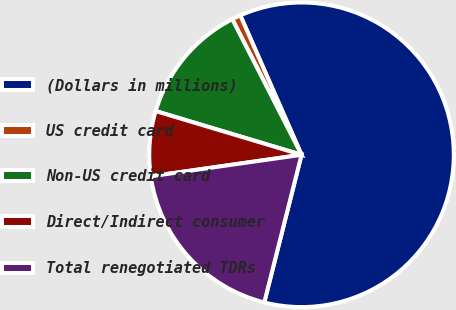Convert chart. <chart><loc_0><loc_0><loc_500><loc_500><pie_chart><fcel>(Dollars in millions)<fcel>US credit card<fcel>Non-US credit card<fcel>Direct/Indirect consumer<fcel>Total renegotiated TDRs<nl><fcel>60.52%<fcel>0.93%<fcel>12.85%<fcel>6.89%<fcel>18.81%<nl></chart> 